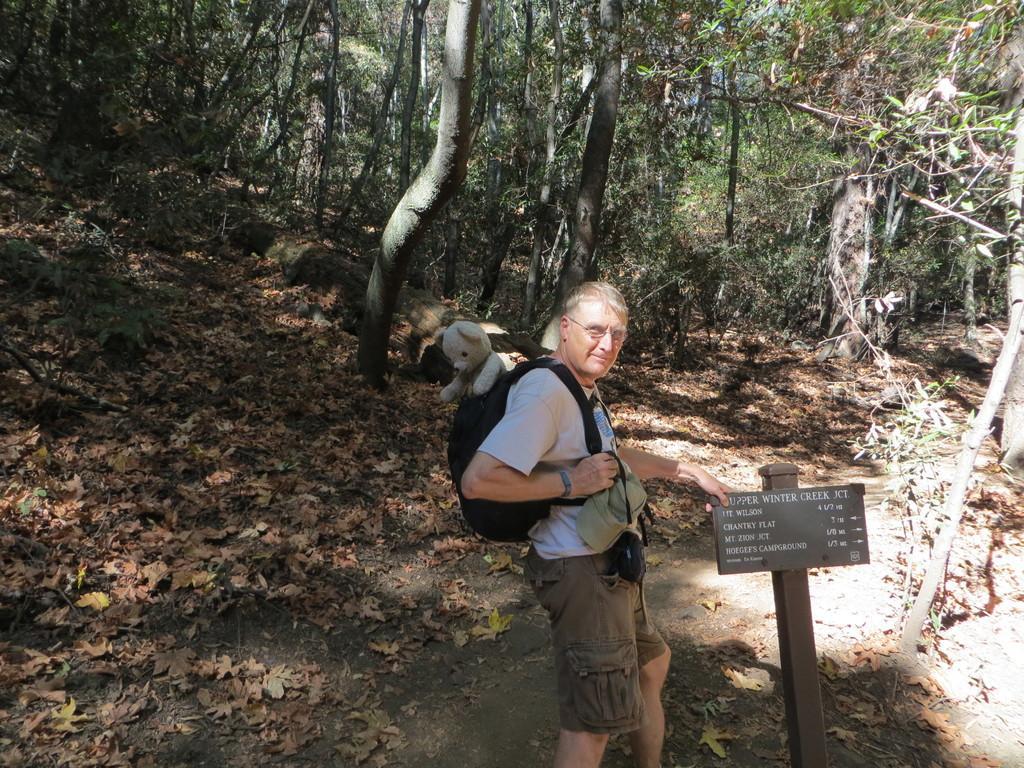In one or two sentences, can you explain what this image depicts? In this picture there is an old man wearing white t-shirt and standing in the forest and giving a pose to the camera. Beside there is a caution board. In the background there are some trees and dry leaves. 